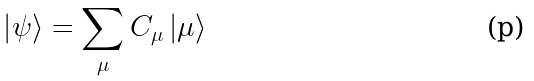Convert formula to latex. <formula><loc_0><loc_0><loc_500><loc_500>\left | \psi \right \rangle = \sum _ { \mu } C _ { \mu } \left | \mu \right \rangle</formula> 